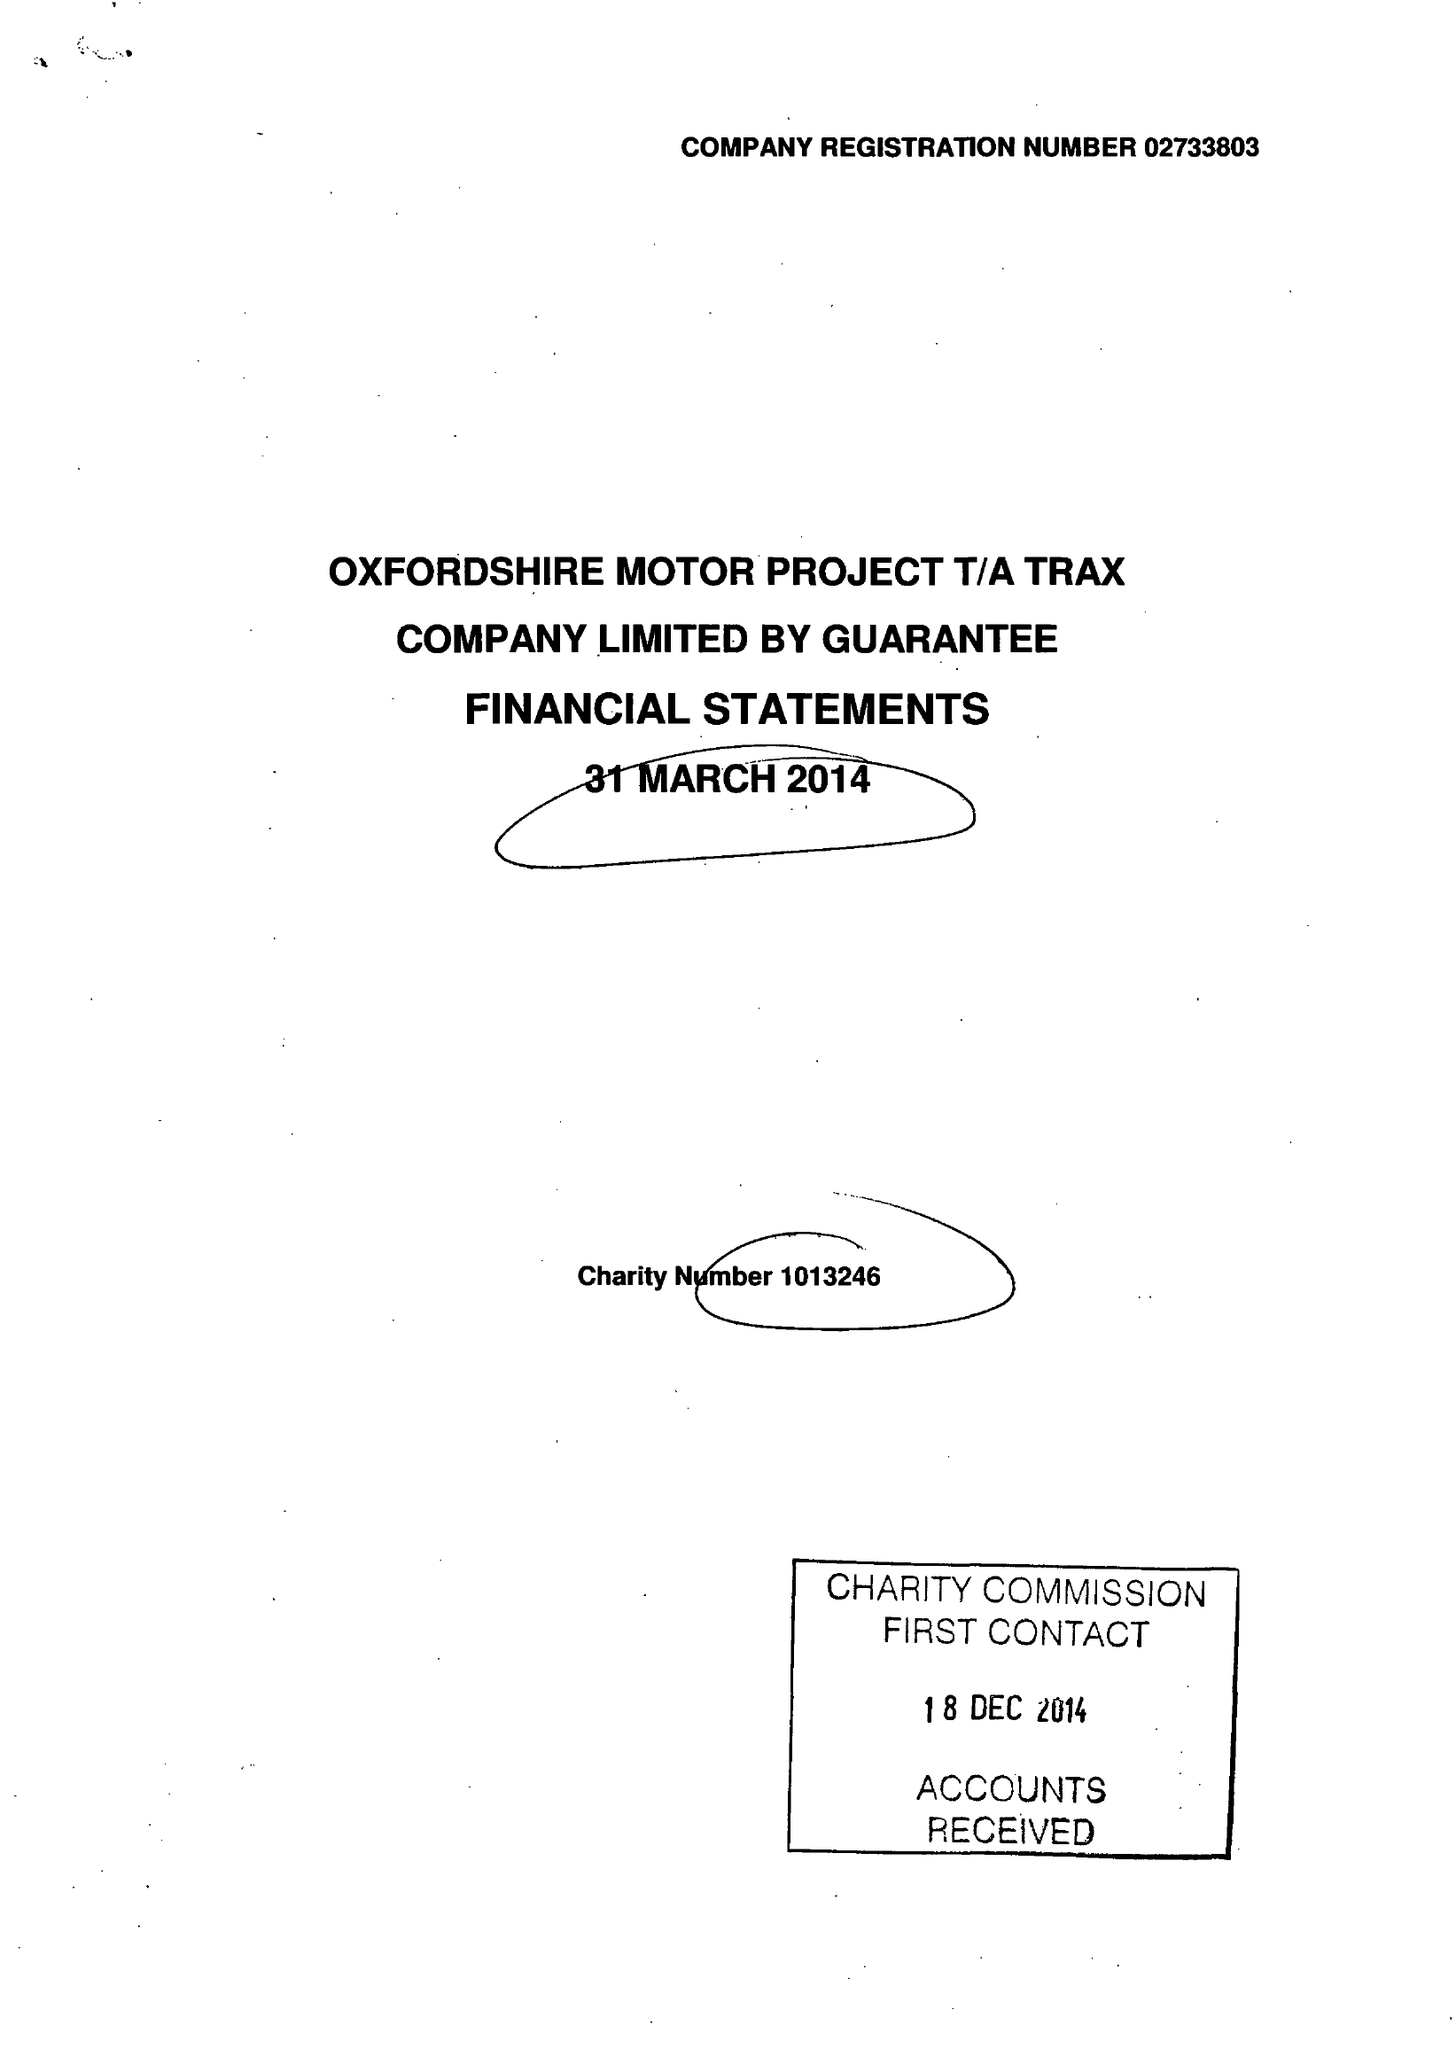What is the value for the income_annually_in_british_pounds?
Answer the question using a single word or phrase. 305134.00 